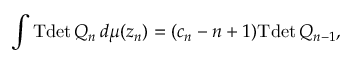Convert formula to latex. <formula><loc_0><loc_0><loc_500><loc_500>\int T d e t \, Q _ { n } \, d \mu ( z _ { n } ) = ( c _ { n } - n + 1 ) T d e t \, Q _ { n - 1 } ,</formula> 